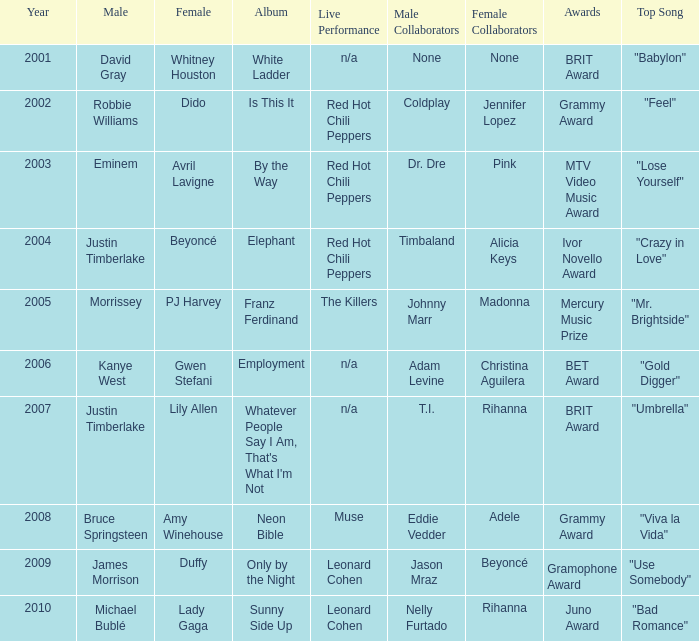Which female artist has an album named elephant? Beyoncé. 